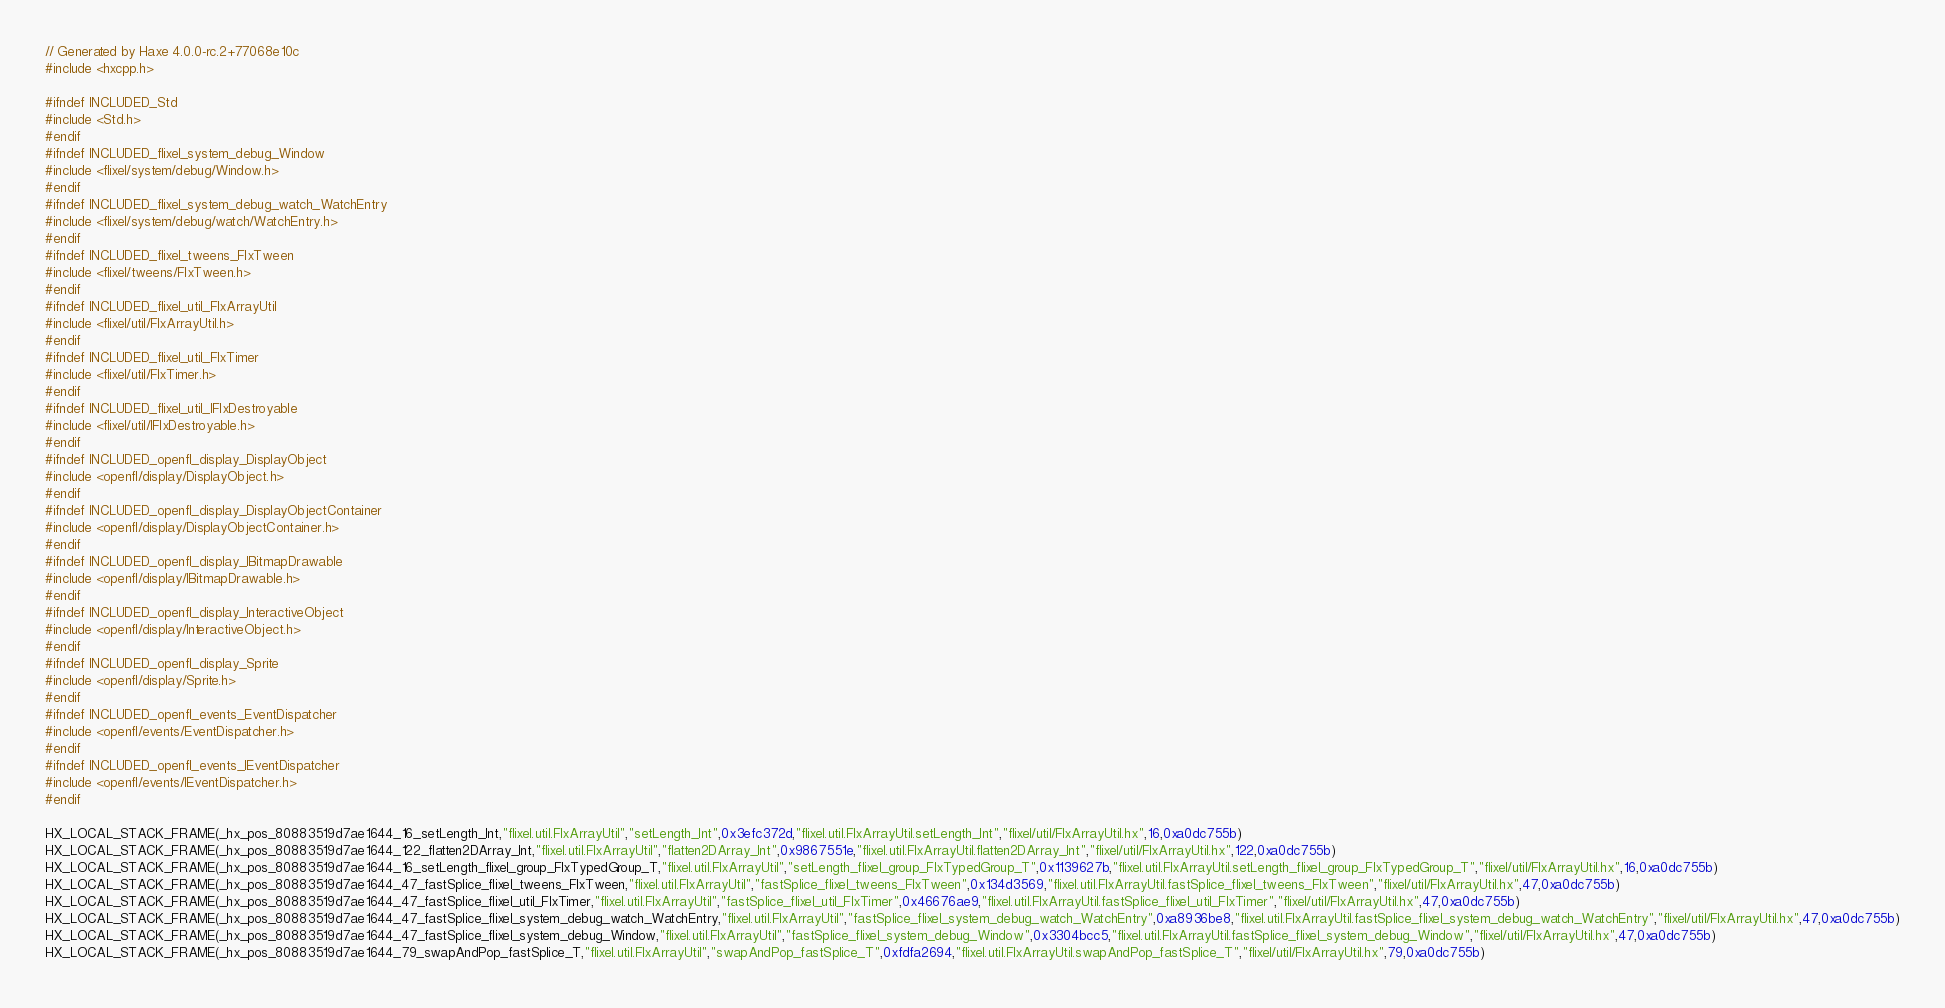Convert code to text. <code><loc_0><loc_0><loc_500><loc_500><_C++_>// Generated by Haxe 4.0.0-rc.2+77068e10c
#include <hxcpp.h>

#ifndef INCLUDED_Std
#include <Std.h>
#endif
#ifndef INCLUDED_flixel_system_debug_Window
#include <flixel/system/debug/Window.h>
#endif
#ifndef INCLUDED_flixel_system_debug_watch_WatchEntry
#include <flixel/system/debug/watch/WatchEntry.h>
#endif
#ifndef INCLUDED_flixel_tweens_FlxTween
#include <flixel/tweens/FlxTween.h>
#endif
#ifndef INCLUDED_flixel_util_FlxArrayUtil
#include <flixel/util/FlxArrayUtil.h>
#endif
#ifndef INCLUDED_flixel_util_FlxTimer
#include <flixel/util/FlxTimer.h>
#endif
#ifndef INCLUDED_flixel_util_IFlxDestroyable
#include <flixel/util/IFlxDestroyable.h>
#endif
#ifndef INCLUDED_openfl_display_DisplayObject
#include <openfl/display/DisplayObject.h>
#endif
#ifndef INCLUDED_openfl_display_DisplayObjectContainer
#include <openfl/display/DisplayObjectContainer.h>
#endif
#ifndef INCLUDED_openfl_display_IBitmapDrawable
#include <openfl/display/IBitmapDrawable.h>
#endif
#ifndef INCLUDED_openfl_display_InteractiveObject
#include <openfl/display/InteractiveObject.h>
#endif
#ifndef INCLUDED_openfl_display_Sprite
#include <openfl/display/Sprite.h>
#endif
#ifndef INCLUDED_openfl_events_EventDispatcher
#include <openfl/events/EventDispatcher.h>
#endif
#ifndef INCLUDED_openfl_events_IEventDispatcher
#include <openfl/events/IEventDispatcher.h>
#endif

HX_LOCAL_STACK_FRAME(_hx_pos_80883519d7ae1644_16_setLength_Int,"flixel.util.FlxArrayUtil","setLength_Int",0x3efc372d,"flixel.util.FlxArrayUtil.setLength_Int","flixel/util/FlxArrayUtil.hx",16,0xa0dc755b)
HX_LOCAL_STACK_FRAME(_hx_pos_80883519d7ae1644_122_flatten2DArray_Int,"flixel.util.FlxArrayUtil","flatten2DArray_Int",0x9867551e,"flixel.util.FlxArrayUtil.flatten2DArray_Int","flixel/util/FlxArrayUtil.hx",122,0xa0dc755b)
HX_LOCAL_STACK_FRAME(_hx_pos_80883519d7ae1644_16_setLength_flixel_group_FlxTypedGroup_T,"flixel.util.FlxArrayUtil","setLength_flixel_group_FlxTypedGroup_T",0x1139627b,"flixel.util.FlxArrayUtil.setLength_flixel_group_FlxTypedGroup_T","flixel/util/FlxArrayUtil.hx",16,0xa0dc755b)
HX_LOCAL_STACK_FRAME(_hx_pos_80883519d7ae1644_47_fastSplice_flixel_tweens_FlxTween,"flixel.util.FlxArrayUtil","fastSplice_flixel_tweens_FlxTween",0x134d3569,"flixel.util.FlxArrayUtil.fastSplice_flixel_tweens_FlxTween","flixel/util/FlxArrayUtil.hx",47,0xa0dc755b)
HX_LOCAL_STACK_FRAME(_hx_pos_80883519d7ae1644_47_fastSplice_flixel_util_FlxTimer,"flixel.util.FlxArrayUtil","fastSplice_flixel_util_FlxTimer",0x46676ae9,"flixel.util.FlxArrayUtil.fastSplice_flixel_util_FlxTimer","flixel/util/FlxArrayUtil.hx",47,0xa0dc755b)
HX_LOCAL_STACK_FRAME(_hx_pos_80883519d7ae1644_47_fastSplice_flixel_system_debug_watch_WatchEntry,"flixel.util.FlxArrayUtil","fastSplice_flixel_system_debug_watch_WatchEntry",0xa8936be8,"flixel.util.FlxArrayUtil.fastSplice_flixel_system_debug_watch_WatchEntry","flixel/util/FlxArrayUtil.hx",47,0xa0dc755b)
HX_LOCAL_STACK_FRAME(_hx_pos_80883519d7ae1644_47_fastSplice_flixel_system_debug_Window,"flixel.util.FlxArrayUtil","fastSplice_flixel_system_debug_Window",0x3304bcc5,"flixel.util.FlxArrayUtil.fastSplice_flixel_system_debug_Window","flixel/util/FlxArrayUtil.hx",47,0xa0dc755b)
HX_LOCAL_STACK_FRAME(_hx_pos_80883519d7ae1644_79_swapAndPop_fastSplice_T,"flixel.util.FlxArrayUtil","swapAndPop_fastSplice_T",0xfdfa2694,"flixel.util.FlxArrayUtil.swapAndPop_fastSplice_T","flixel/util/FlxArrayUtil.hx",79,0xa0dc755b)</code> 